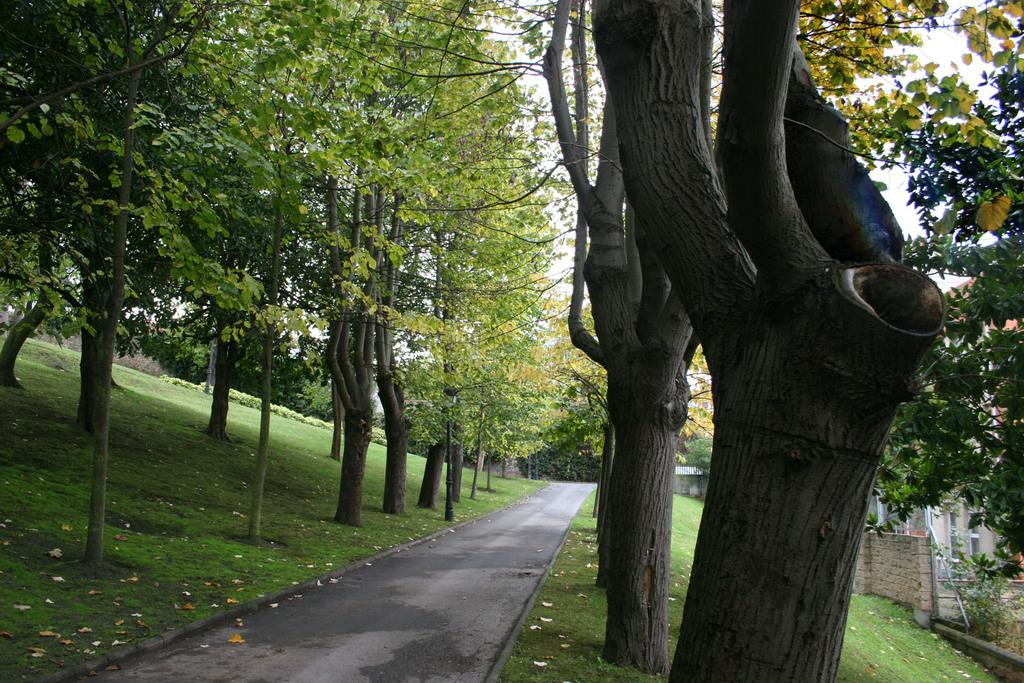What type of vegetation can be seen in the image? There are trees in the image. What is located between the trees? There is a road between the trees. What type of ground cover is visible in the image? Grass is visible in the image. What type of structure can be seen in the image? There is a wall in the image. What is the color of the sky in the image? The sky is white in the image. Can you see any icicles hanging from the trees in the image? There are no icicles present in the image; it appears to be a warm and sunny day. Is there a writer sitting on the grass in the image? There is no writer present in the image; it only shows trees, a road, grass, a wall, and a white sky. 